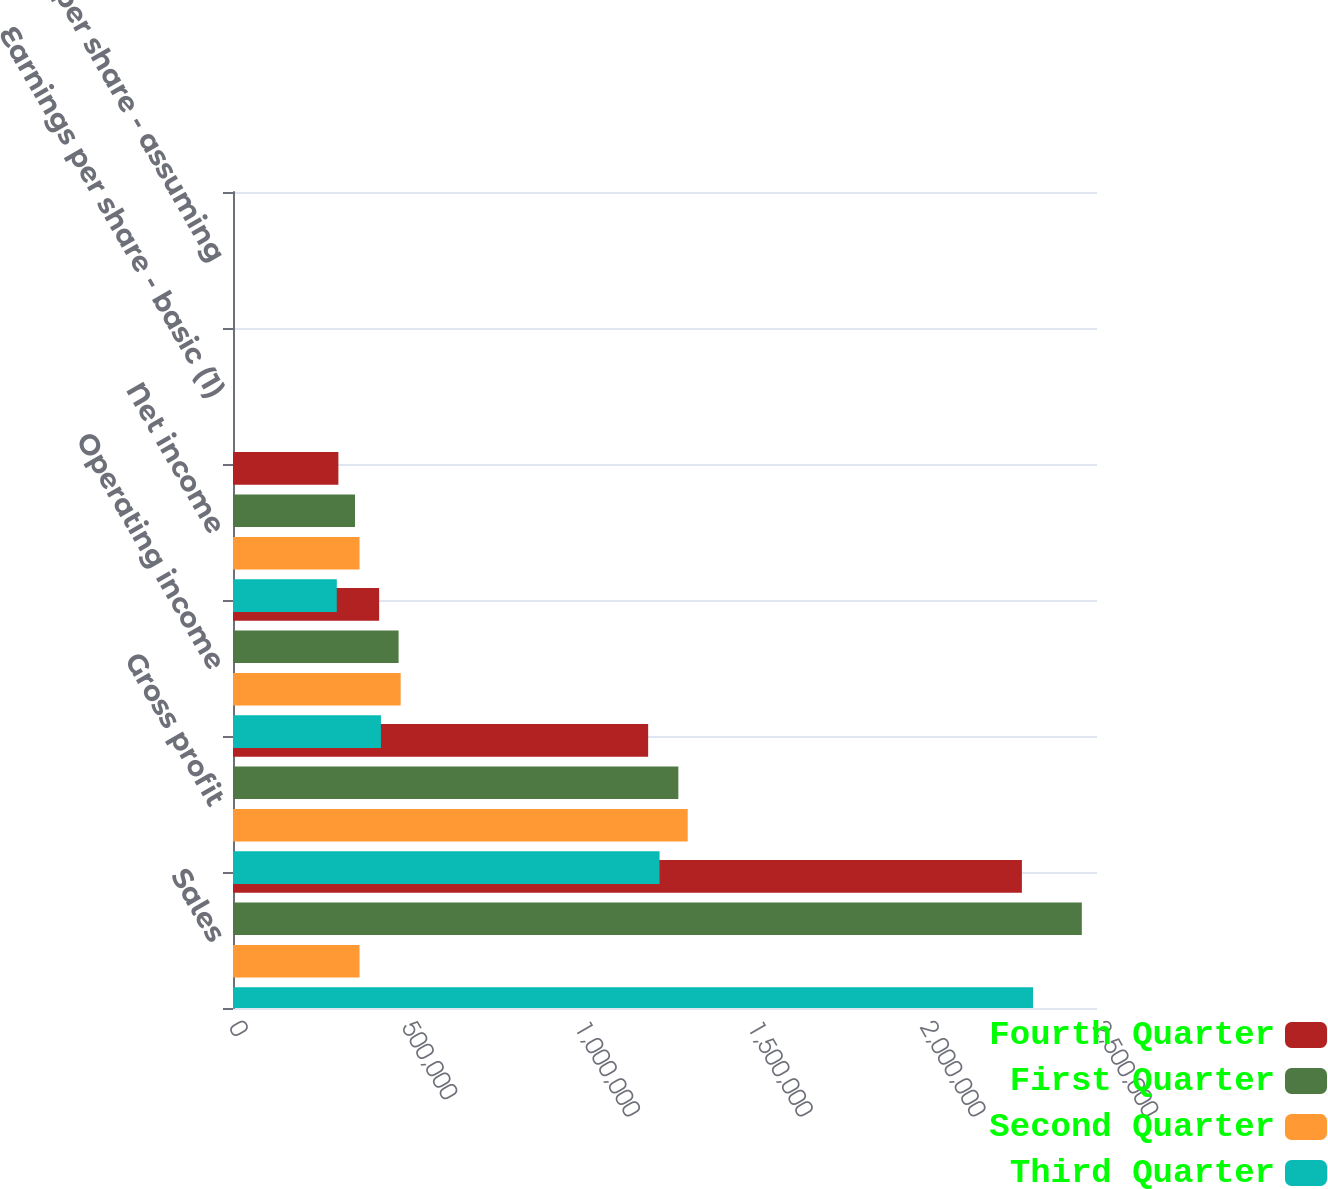Convert chart. <chart><loc_0><loc_0><loc_500><loc_500><stacked_bar_chart><ecel><fcel>Sales<fcel>Gross profit<fcel>Operating income<fcel>Net income<fcel>Earnings per share - basic (1)<fcel>Earnings per share - assuming<nl><fcel>Fourth Quarter<fcel>2.28268e+06<fcel>1.20126e+06<fcel>422846<fcel>304906<fcel>3.65<fcel>3.61<nl><fcel>First Quarter<fcel>2.45607e+06<fcel>1.28864e+06<fcel>479150<fcel>353073<fcel>4.32<fcel>4.28<nl><fcel>Second Quarter<fcel>366151<fcel>1.31576e+06<fcel>485148<fcel>366151<fcel>4.54<fcel>4.5<nl><fcel>Third Quarter<fcel>2.31496e+06<fcel>1.23432e+06<fcel>428040<fcel>300357<fcel>3.76<fcel>3.72<nl></chart> 